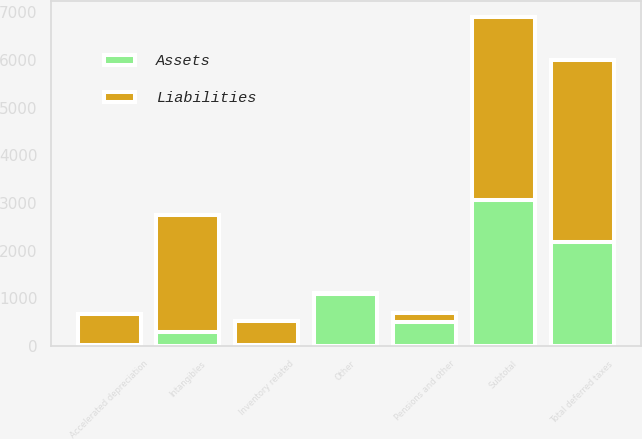Convert chart. <chart><loc_0><loc_0><loc_500><loc_500><stacked_bar_chart><ecel><fcel>Intangibles<fcel>Inventory related<fcel>Accelerated depreciation<fcel>Pensions and other<fcel>Other<fcel>Subtotal<fcel>Total deferred taxes<nl><fcel>Assets<fcel>307<fcel>29<fcel>28<fcel>498<fcel>1088<fcel>3074<fcel>2174<nl><fcel>Liabilities<fcel>2435<fcel>499<fcel>642<fcel>192<fcel>19<fcel>3820<fcel>3820<nl></chart> 